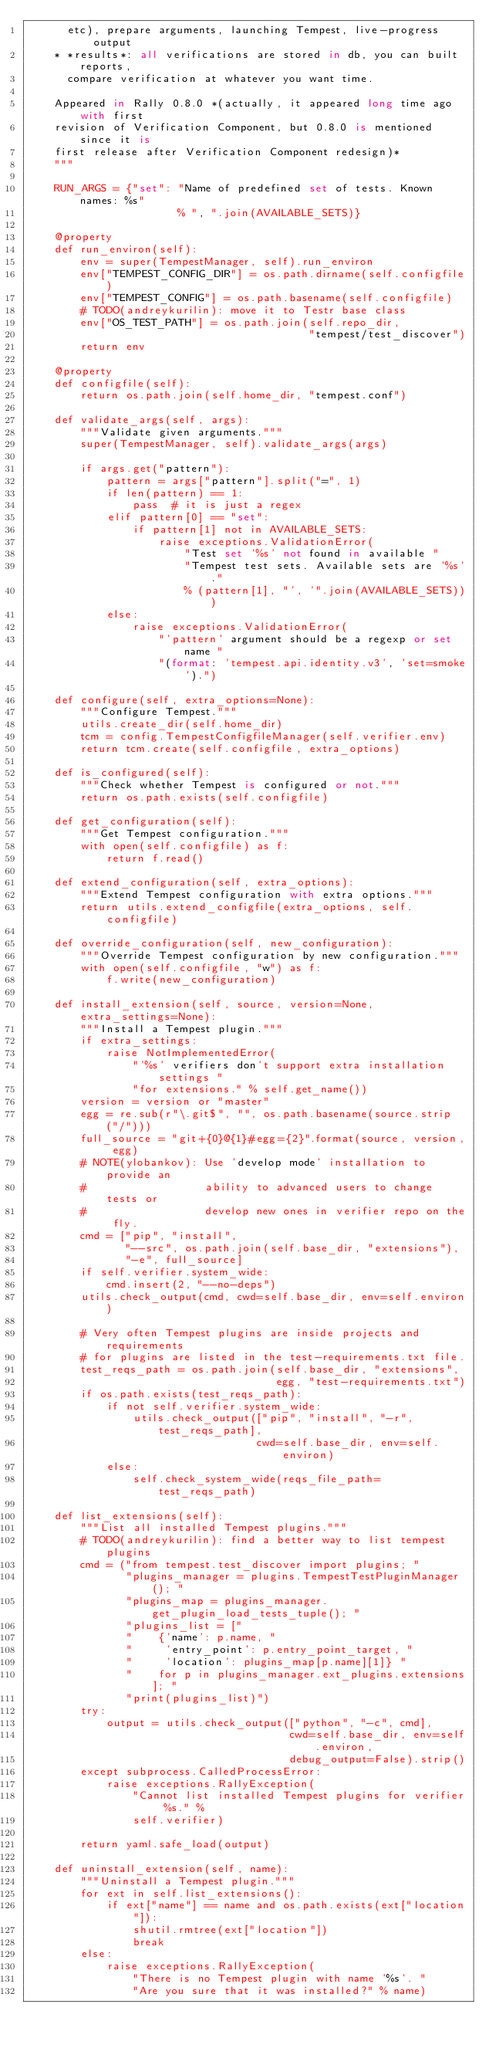Convert code to text. <code><loc_0><loc_0><loc_500><loc_500><_Python_>      etc), prepare arguments, launching Tempest, live-progress output
    * *results*: all verifications are stored in db, you can built reports,
      compare verification at whatever you want time.

    Appeared in Rally 0.8.0 *(actually, it appeared long time ago with first
    revision of Verification Component, but 0.8.0 is mentioned since it is
    first release after Verification Component redesign)*
    """

    RUN_ARGS = {"set": "Name of predefined set of tests. Known names: %s"
                       % ", ".join(AVAILABLE_SETS)}

    @property
    def run_environ(self):
        env = super(TempestManager, self).run_environ
        env["TEMPEST_CONFIG_DIR"] = os.path.dirname(self.configfile)
        env["TEMPEST_CONFIG"] = os.path.basename(self.configfile)
        # TODO(andreykurilin): move it to Testr base class
        env["OS_TEST_PATH"] = os.path.join(self.repo_dir,
                                           "tempest/test_discover")
        return env

    @property
    def configfile(self):
        return os.path.join(self.home_dir, "tempest.conf")

    def validate_args(self, args):
        """Validate given arguments."""
        super(TempestManager, self).validate_args(args)

        if args.get("pattern"):
            pattern = args["pattern"].split("=", 1)
            if len(pattern) == 1:
                pass  # it is just a regex
            elif pattern[0] == "set":
                if pattern[1] not in AVAILABLE_SETS:
                    raise exceptions.ValidationError(
                        "Test set '%s' not found in available "
                        "Tempest test sets. Available sets are '%s'."
                        % (pattern[1], "', '".join(AVAILABLE_SETS)))
            else:
                raise exceptions.ValidationError(
                    "'pattern' argument should be a regexp or set name "
                    "(format: 'tempest.api.identity.v3', 'set=smoke').")

    def configure(self, extra_options=None):
        """Configure Tempest."""
        utils.create_dir(self.home_dir)
        tcm = config.TempestConfigfileManager(self.verifier.env)
        return tcm.create(self.configfile, extra_options)

    def is_configured(self):
        """Check whether Tempest is configured or not."""
        return os.path.exists(self.configfile)

    def get_configuration(self):
        """Get Tempest configuration."""
        with open(self.configfile) as f:
            return f.read()

    def extend_configuration(self, extra_options):
        """Extend Tempest configuration with extra options."""
        return utils.extend_configfile(extra_options, self.configfile)

    def override_configuration(self, new_configuration):
        """Override Tempest configuration by new configuration."""
        with open(self.configfile, "w") as f:
            f.write(new_configuration)

    def install_extension(self, source, version=None, extra_settings=None):
        """Install a Tempest plugin."""
        if extra_settings:
            raise NotImplementedError(
                "'%s' verifiers don't support extra installation settings "
                "for extensions." % self.get_name())
        version = version or "master"
        egg = re.sub(r"\.git$", "", os.path.basename(source.strip("/")))
        full_source = "git+{0}@{1}#egg={2}".format(source, version, egg)
        # NOTE(ylobankov): Use 'develop mode' installation to provide an
        #                  ability to advanced users to change tests or
        #                  develop new ones in verifier repo on the fly.
        cmd = ["pip", "install",
               "--src", os.path.join(self.base_dir, "extensions"),
               "-e", full_source]
        if self.verifier.system_wide:
            cmd.insert(2, "--no-deps")
        utils.check_output(cmd, cwd=self.base_dir, env=self.environ)

        # Very often Tempest plugins are inside projects and requirements
        # for plugins are listed in the test-requirements.txt file.
        test_reqs_path = os.path.join(self.base_dir, "extensions",
                                      egg, "test-requirements.txt")
        if os.path.exists(test_reqs_path):
            if not self.verifier.system_wide:
                utils.check_output(["pip", "install", "-r", test_reqs_path],
                                   cwd=self.base_dir, env=self.environ)
            else:
                self.check_system_wide(reqs_file_path=test_reqs_path)

    def list_extensions(self):
        """List all installed Tempest plugins."""
        # TODO(andreykurilin): find a better way to list tempest plugins
        cmd = ("from tempest.test_discover import plugins; "
               "plugins_manager = plugins.TempestTestPluginManager(); "
               "plugins_map = plugins_manager.get_plugin_load_tests_tuple(); "
               "plugins_list = ["
               "    {'name': p.name, "
               "     'entry_point': p.entry_point_target, "
               "     'location': plugins_map[p.name][1]} "
               "    for p in plugins_manager.ext_plugins.extensions]; "
               "print(plugins_list)")
        try:
            output = utils.check_output(["python", "-c", cmd],
                                        cwd=self.base_dir, env=self.environ,
                                        debug_output=False).strip()
        except subprocess.CalledProcessError:
            raise exceptions.RallyException(
                "Cannot list installed Tempest plugins for verifier %s." %
                self.verifier)

        return yaml.safe_load(output)

    def uninstall_extension(self, name):
        """Uninstall a Tempest plugin."""
        for ext in self.list_extensions():
            if ext["name"] == name and os.path.exists(ext["location"]):
                shutil.rmtree(ext["location"])
                break
        else:
            raise exceptions.RallyException(
                "There is no Tempest plugin with name '%s'. "
                "Are you sure that it was installed?" % name)
</code> 